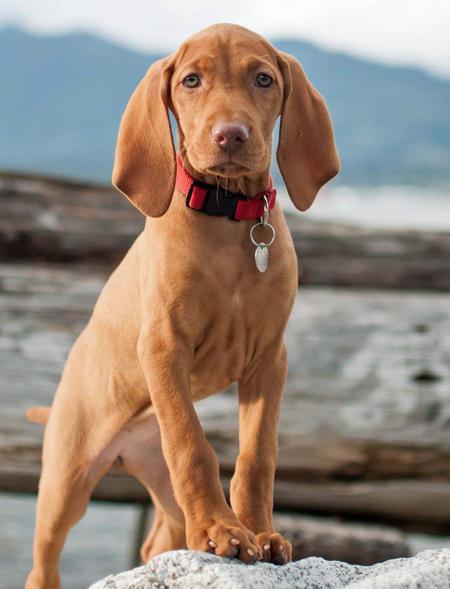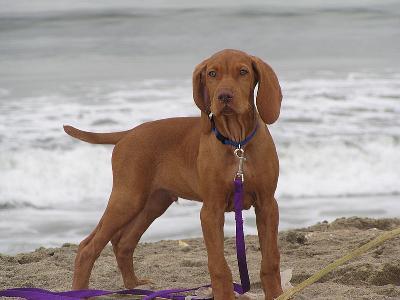The first image is the image on the left, the second image is the image on the right. Assess this claim about the two images: "A single dog in the image on the left is sitting up.". Correct or not? Answer yes or no. No. The first image is the image on the left, the second image is the image on the right. Given the left and right images, does the statement "Each image contains only one dog, the left image features a dog turned forward and sitting upright, and the right image features a rightward-turned dog wearing a collar." hold true? Answer yes or no. No. 